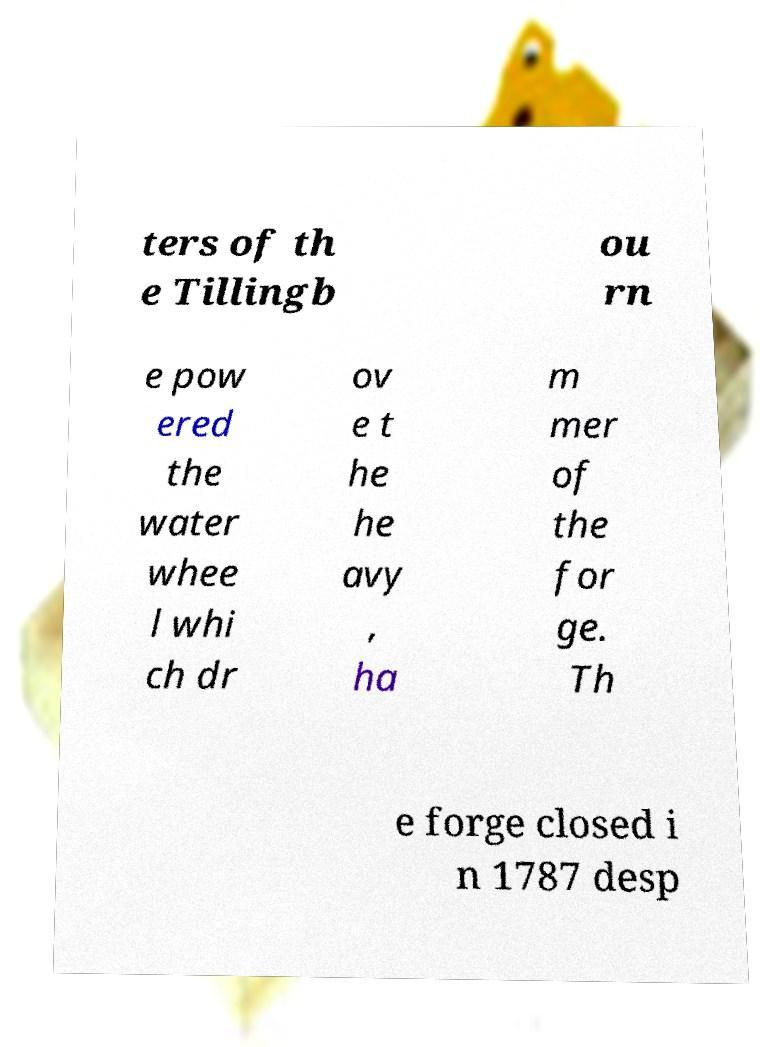Please identify and transcribe the text found in this image. ters of th e Tillingb ou rn e pow ered the water whee l whi ch dr ov e t he he avy , ha m mer of the for ge. Th e forge closed i n 1787 desp 